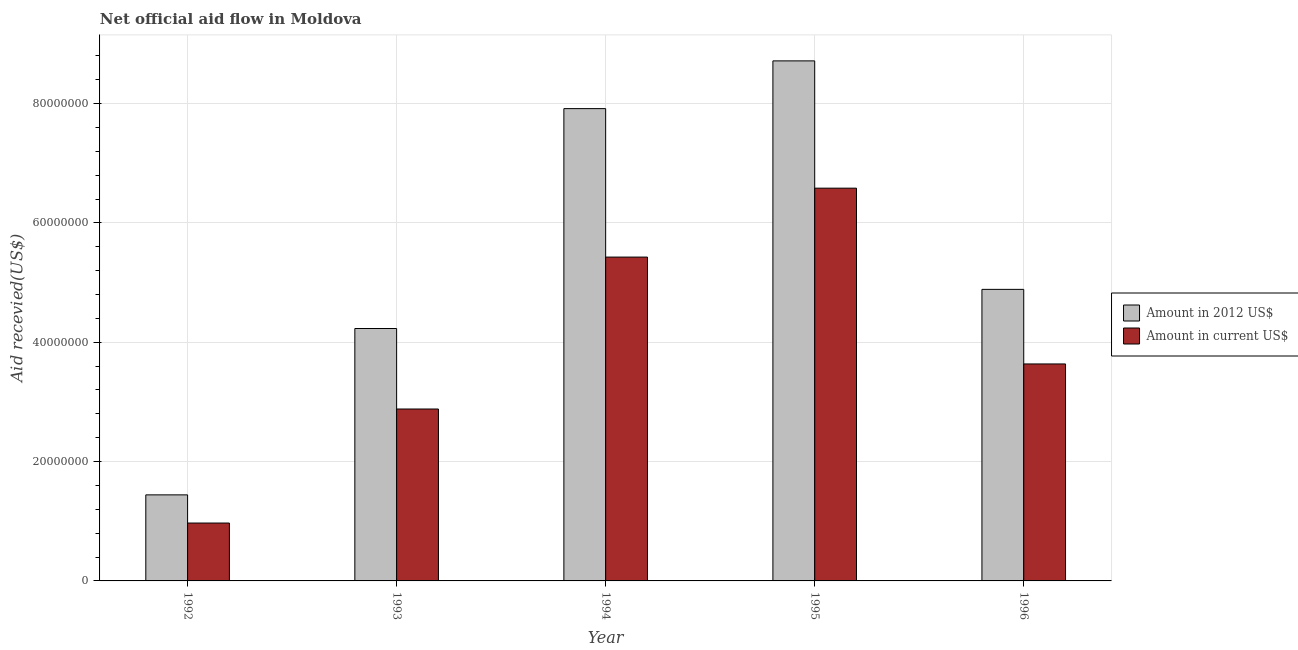How many different coloured bars are there?
Offer a very short reply. 2. What is the label of the 4th group of bars from the left?
Your answer should be compact. 1995. What is the amount of aid received(expressed in 2012 us$) in 1993?
Offer a terse response. 4.23e+07. Across all years, what is the maximum amount of aid received(expressed in us$)?
Your response must be concise. 6.58e+07. Across all years, what is the minimum amount of aid received(expressed in 2012 us$)?
Give a very brief answer. 1.44e+07. What is the total amount of aid received(expressed in 2012 us$) in the graph?
Provide a succinct answer. 2.72e+08. What is the difference between the amount of aid received(expressed in 2012 us$) in 1992 and that in 1993?
Your response must be concise. -2.79e+07. What is the difference between the amount of aid received(expressed in 2012 us$) in 1992 and the amount of aid received(expressed in us$) in 1994?
Offer a very short reply. -6.47e+07. What is the average amount of aid received(expressed in 2012 us$) per year?
Ensure brevity in your answer.  5.44e+07. What is the ratio of the amount of aid received(expressed in 2012 us$) in 1994 to that in 1996?
Your answer should be compact. 1.62. Is the amount of aid received(expressed in us$) in 1993 less than that in 1994?
Provide a succinct answer. Yes. What is the difference between the highest and the lowest amount of aid received(expressed in 2012 us$)?
Your answer should be compact. 7.27e+07. What does the 2nd bar from the left in 1993 represents?
Make the answer very short. Amount in current US$. What does the 2nd bar from the right in 1992 represents?
Keep it short and to the point. Amount in 2012 US$. Are all the bars in the graph horizontal?
Provide a short and direct response. No. What is the difference between two consecutive major ticks on the Y-axis?
Offer a very short reply. 2.00e+07. Are the values on the major ticks of Y-axis written in scientific E-notation?
Provide a short and direct response. No. Does the graph contain any zero values?
Provide a short and direct response. No. Where does the legend appear in the graph?
Give a very brief answer. Center right. How many legend labels are there?
Provide a short and direct response. 2. What is the title of the graph?
Your answer should be very brief. Net official aid flow in Moldova. Does "% of GNI" appear as one of the legend labels in the graph?
Ensure brevity in your answer.  No. What is the label or title of the X-axis?
Keep it short and to the point. Year. What is the label or title of the Y-axis?
Ensure brevity in your answer.  Aid recevied(US$). What is the Aid recevied(US$) of Amount in 2012 US$ in 1992?
Give a very brief answer. 1.44e+07. What is the Aid recevied(US$) in Amount in current US$ in 1992?
Make the answer very short. 9.70e+06. What is the Aid recevied(US$) in Amount in 2012 US$ in 1993?
Provide a succinct answer. 4.23e+07. What is the Aid recevied(US$) in Amount in current US$ in 1993?
Your answer should be very brief. 2.88e+07. What is the Aid recevied(US$) of Amount in 2012 US$ in 1994?
Your answer should be compact. 7.92e+07. What is the Aid recevied(US$) in Amount in current US$ in 1994?
Your response must be concise. 5.43e+07. What is the Aid recevied(US$) of Amount in 2012 US$ in 1995?
Make the answer very short. 8.72e+07. What is the Aid recevied(US$) of Amount in current US$ in 1995?
Offer a terse response. 6.58e+07. What is the Aid recevied(US$) in Amount in 2012 US$ in 1996?
Give a very brief answer. 4.89e+07. What is the Aid recevied(US$) of Amount in current US$ in 1996?
Your answer should be compact. 3.64e+07. Across all years, what is the maximum Aid recevied(US$) of Amount in 2012 US$?
Make the answer very short. 8.72e+07. Across all years, what is the maximum Aid recevied(US$) of Amount in current US$?
Offer a very short reply. 6.58e+07. Across all years, what is the minimum Aid recevied(US$) of Amount in 2012 US$?
Keep it short and to the point. 1.44e+07. Across all years, what is the minimum Aid recevied(US$) of Amount in current US$?
Your answer should be very brief. 9.70e+06. What is the total Aid recevied(US$) of Amount in 2012 US$ in the graph?
Your response must be concise. 2.72e+08. What is the total Aid recevied(US$) of Amount in current US$ in the graph?
Offer a terse response. 1.95e+08. What is the difference between the Aid recevied(US$) in Amount in 2012 US$ in 1992 and that in 1993?
Offer a very short reply. -2.79e+07. What is the difference between the Aid recevied(US$) of Amount in current US$ in 1992 and that in 1993?
Keep it short and to the point. -1.91e+07. What is the difference between the Aid recevied(US$) of Amount in 2012 US$ in 1992 and that in 1994?
Offer a very short reply. -6.47e+07. What is the difference between the Aid recevied(US$) in Amount in current US$ in 1992 and that in 1994?
Your answer should be compact. -4.46e+07. What is the difference between the Aid recevied(US$) of Amount in 2012 US$ in 1992 and that in 1995?
Ensure brevity in your answer.  -7.27e+07. What is the difference between the Aid recevied(US$) in Amount in current US$ in 1992 and that in 1995?
Your response must be concise. -5.61e+07. What is the difference between the Aid recevied(US$) in Amount in 2012 US$ in 1992 and that in 1996?
Provide a short and direct response. -3.44e+07. What is the difference between the Aid recevied(US$) of Amount in current US$ in 1992 and that in 1996?
Offer a very short reply. -2.67e+07. What is the difference between the Aid recevied(US$) of Amount in 2012 US$ in 1993 and that in 1994?
Give a very brief answer. -3.68e+07. What is the difference between the Aid recevied(US$) in Amount in current US$ in 1993 and that in 1994?
Provide a short and direct response. -2.55e+07. What is the difference between the Aid recevied(US$) in Amount in 2012 US$ in 1993 and that in 1995?
Give a very brief answer. -4.48e+07. What is the difference between the Aid recevied(US$) of Amount in current US$ in 1993 and that in 1995?
Make the answer very short. -3.70e+07. What is the difference between the Aid recevied(US$) in Amount in 2012 US$ in 1993 and that in 1996?
Your answer should be compact. -6.56e+06. What is the difference between the Aid recevied(US$) in Amount in current US$ in 1993 and that in 1996?
Offer a very short reply. -7.55e+06. What is the difference between the Aid recevied(US$) of Amount in 2012 US$ in 1994 and that in 1995?
Provide a succinct answer. -8.00e+06. What is the difference between the Aid recevied(US$) of Amount in current US$ in 1994 and that in 1995?
Offer a terse response. -1.16e+07. What is the difference between the Aid recevied(US$) of Amount in 2012 US$ in 1994 and that in 1996?
Make the answer very short. 3.03e+07. What is the difference between the Aid recevied(US$) of Amount in current US$ in 1994 and that in 1996?
Keep it short and to the point. 1.79e+07. What is the difference between the Aid recevied(US$) of Amount in 2012 US$ in 1995 and that in 1996?
Provide a short and direct response. 3.83e+07. What is the difference between the Aid recevied(US$) in Amount in current US$ in 1995 and that in 1996?
Ensure brevity in your answer.  2.95e+07. What is the difference between the Aid recevied(US$) of Amount in 2012 US$ in 1992 and the Aid recevied(US$) of Amount in current US$ in 1993?
Offer a terse response. -1.44e+07. What is the difference between the Aid recevied(US$) in Amount in 2012 US$ in 1992 and the Aid recevied(US$) in Amount in current US$ in 1994?
Provide a succinct answer. -3.98e+07. What is the difference between the Aid recevied(US$) in Amount in 2012 US$ in 1992 and the Aid recevied(US$) in Amount in current US$ in 1995?
Your answer should be compact. -5.14e+07. What is the difference between the Aid recevied(US$) of Amount in 2012 US$ in 1992 and the Aid recevied(US$) of Amount in current US$ in 1996?
Offer a terse response. -2.19e+07. What is the difference between the Aid recevied(US$) of Amount in 2012 US$ in 1993 and the Aid recevied(US$) of Amount in current US$ in 1994?
Provide a short and direct response. -1.20e+07. What is the difference between the Aid recevied(US$) in Amount in 2012 US$ in 1993 and the Aid recevied(US$) in Amount in current US$ in 1995?
Offer a terse response. -2.35e+07. What is the difference between the Aid recevied(US$) in Amount in 2012 US$ in 1993 and the Aid recevied(US$) in Amount in current US$ in 1996?
Your response must be concise. 5.94e+06. What is the difference between the Aid recevied(US$) in Amount in 2012 US$ in 1994 and the Aid recevied(US$) in Amount in current US$ in 1995?
Make the answer very short. 1.33e+07. What is the difference between the Aid recevied(US$) of Amount in 2012 US$ in 1994 and the Aid recevied(US$) of Amount in current US$ in 1996?
Provide a short and direct response. 4.28e+07. What is the difference between the Aid recevied(US$) in Amount in 2012 US$ in 1995 and the Aid recevied(US$) in Amount in current US$ in 1996?
Offer a very short reply. 5.08e+07. What is the average Aid recevied(US$) in Amount in 2012 US$ per year?
Offer a very short reply. 5.44e+07. What is the average Aid recevied(US$) of Amount in current US$ per year?
Offer a terse response. 3.90e+07. In the year 1992, what is the difference between the Aid recevied(US$) in Amount in 2012 US$ and Aid recevied(US$) in Amount in current US$?
Offer a terse response. 4.72e+06. In the year 1993, what is the difference between the Aid recevied(US$) in Amount in 2012 US$ and Aid recevied(US$) in Amount in current US$?
Provide a succinct answer. 1.35e+07. In the year 1994, what is the difference between the Aid recevied(US$) in Amount in 2012 US$ and Aid recevied(US$) in Amount in current US$?
Your answer should be compact. 2.49e+07. In the year 1995, what is the difference between the Aid recevied(US$) in Amount in 2012 US$ and Aid recevied(US$) in Amount in current US$?
Ensure brevity in your answer.  2.13e+07. In the year 1996, what is the difference between the Aid recevied(US$) in Amount in 2012 US$ and Aid recevied(US$) in Amount in current US$?
Offer a terse response. 1.25e+07. What is the ratio of the Aid recevied(US$) of Amount in 2012 US$ in 1992 to that in 1993?
Offer a very short reply. 0.34. What is the ratio of the Aid recevied(US$) of Amount in current US$ in 1992 to that in 1993?
Ensure brevity in your answer.  0.34. What is the ratio of the Aid recevied(US$) in Amount in 2012 US$ in 1992 to that in 1994?
Provide a succinct answer. 0.18. What is the ratio of the Aid recevied(US$) in Amount in current US$ in 1992 to that in 1994?
Make the answer very short. 0.18. What is the ratio of the Aid recevied(US$) of Amount in 2012 US$ in 1992 to that in 1995?
Make the answer very short. 0.17. What is the ratio of the Aid recevied(US$) in Amount in current US$ in 1992 to that in 1995?
Provide a short and direct response. 0.15. What is the ratio of the Aid recevied(US$) in Amount in 2012 US$ in 1992 to that in 1996?
Keep it short and to the point. 0.3. What is the ratio of the Aid recevied(US$) in Amount in current US$ in 1992 to that in 1996?
Your answer should be very brief. 0.27. What is the ratio of the Aid recevied(US$) of Amount in 2012 US$ in 1993 to that in 1994?
Ensure brevity in your answer.  0.53. What is the ratio of the Aid recevied(US$) of Amount in current US$ in 1993 to that in 1994?
Your response must be concise. 0.53. What is the ratio of the Aid recevied(US$) of Amount in 2012 US$ in 1993 to that in 1995?
Give a very brief answer. 0.49. What is the ratio of the Aid recevied(US$) in Amount in current US$ in 1993 to that in 1995?
Your answer should be compact. 0.44. What is the ratio of the Aid recevied(US$) in Amount in 2012 US$ in 1993 to that in 1996?
Provide a succinct answer. 0.87. What is the ratio of the Aid recevied(US$) in Amount in current US$ in 1993 to that in 1996?
Offer a very short reply. 0.79. What is the ratio of the Aid recevied(US$) of Amount in 2012 US$ in 1994 to that in 1995?
Make the answer very short. 0.91. What is the ratio of the Aid recevied(US$) of Amount in current US$ in 1994 to that in 1995?
Offer a very short reply. 0.82. What is the ratio of the Aid recevied(US$) in Amount in 2012 US$ in 1994 to that in 1996?
Give a very brief answer. 1.62. What is the ratio of the Aid recevied(US$) of Amount in current US$ in 1994 to that in 1996?
Your answer should be very brief. 1.49. What is the ratio of the Aid recevied(US$) in Amount in 2012 US$ in 1995 to that in 1996?
Give a very brief answer. 1.78. What is the ratio of the Aid recevied(US$) in Amount in current US$ in 1995 to that in 1996?
Give a very brief answer. 1.81. What is the difference between the highest and the second highest Aid recevied(US$) in Amount in 2012 US$?
Make the answer very short. 8.00e+06. What is the difference between the highest and the second highest Aid recevied(US$) of Amount in current US$?
Offer a very short reply. 1.16e+07. What is the difference between the highest and the lowest Aid recevied(US$) in Amount in 2012 US$?
Your response must be concise. 7.27e+07. What is the difference between the highest and the lowest Aid recevied(US$) in Amount in current US$?
Make the answer very short. 5.61e+07. 